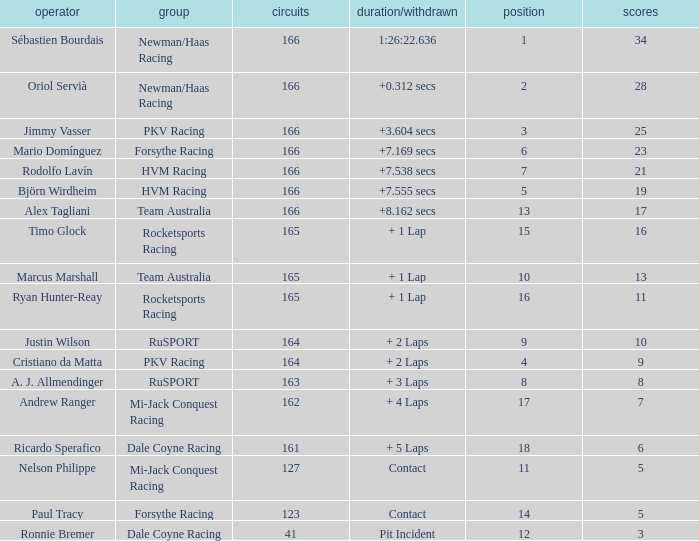Parse the full table. {'header': ['operator', 'group', 'circuits', 'duration/withdrawn', 'position', 'scores'], 'rows': [['Sébastien Bourdais', 'Newman/Haas Racing', '166', '1:26:22.636', '1', '34'], ['Oriol Servià', 'Newman/Haas Racing', '166', '+0.312 secs', '2', '28'], ['Jimmy Vasser', 'PKV Racing', '166', '+3.604 secs', '3', '25'], ['Mario Domínguez', 'Forsythe Racing', '166', '+7.169 secs', '6', '23'], ['Rodolfo Lavín', 'HVM Racing', '166', '+7.538 secs', '7', '21'], ['Björn Wirdheim', 'HVM Racing', '166', '+7.555 secs', '5', '19'], ['Alex Tagliani', 'Team Australia', '166', '+8.162 secs', '13', '17'], ['Timo Glock', 'Rocketsports Racing', '165', '+ 1 Lap', '15', '16'], ['Marcus Marshall', 'Team Australia', '165', '+ 1 Lap', '10', '13'], ['Ryan Hunter-Reay', 'Rocketsports Racing', '165', '+ 1 Lap', '16', '11'], ['Justin Wilson', 'RuSPORT', '164', '+ 2 Laps', '9', '10'], ['Cristiano da Matta', 'PKV Racing', '164', '+ 2 Laps', '4', '9'], ['A. J. Allmendinger', 'RuSPORT', '163', '+ 3 Laps', '8', '8'], ['Andrew Ranger', 'Mi-Jack Conquest Racing', '162', '+ 4 Laps', '17', '7'], ['Ricardo Sperafico', 'Dale Coyne Racing', '161', '+ 5 Laps', '18', '6'], ['Nelson Philippe', 'Mi-Jack Conquest Racing', '127', 'Contact', '11', '5'], ['Paul Tracy', 'Forsythe Racing', '123', 'Contact', '14', '5'], ['Ronnie Bremer', 'Dale Coyne Racing', '41', 'Pit Incident', '12', '3']]} What is the biggest points when the grid is less than 13 and the time/retired is +7.538 secs? 21.0. 